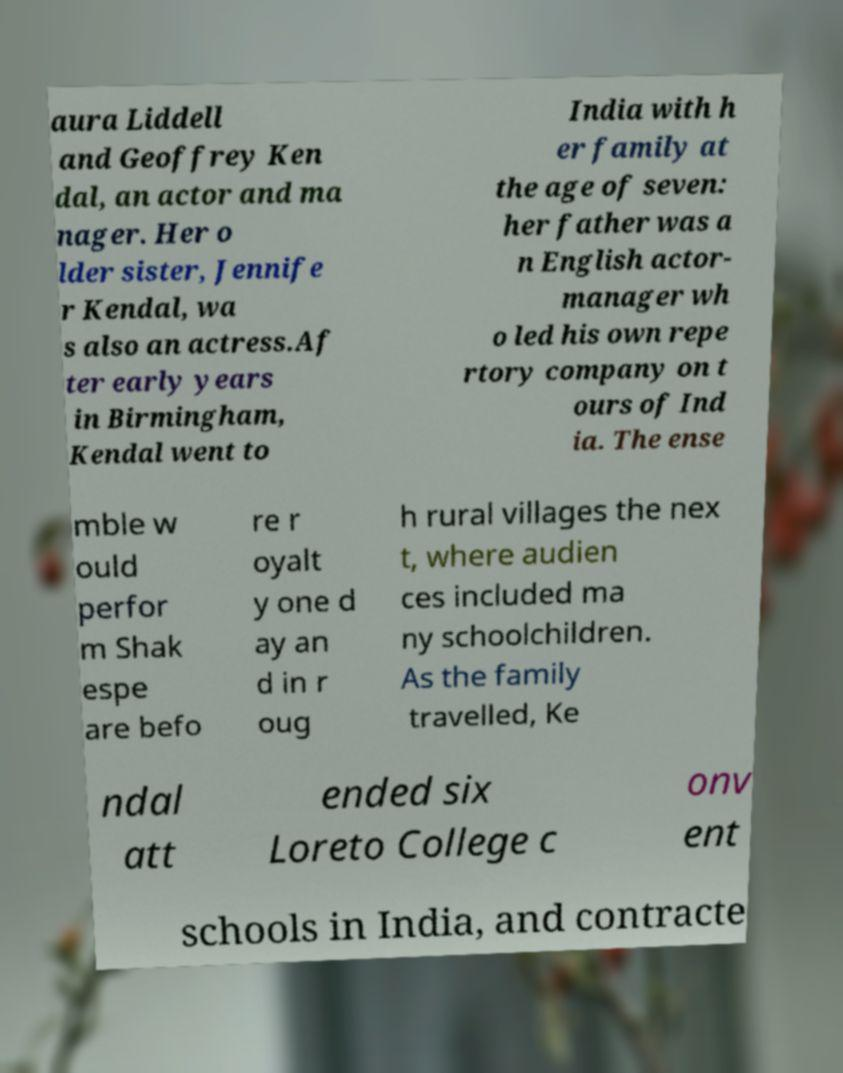Could you assist in decoding the text presented in this image and type it out clearly? aura Liddell and Geoffrey Ken dal, an actor and ma nager. Her o lder sister, Jennife r Kendal, wa s also an actress.Af ter early years in Birmingham, Kendal went to India with h er family at the age of seven: her father was a n English actor- manager wh o led his own repe rtory company on t ours of Ind ia. The ense mble w ould perfor m Shak espe are befo re r oyalt y one d ay an d in r oug h rural villages the nex t, where audien ces included ma ny schoolchildren. As the family travelled, Ke ndal att ended six Loreto College c onv ent schools in India, and contracte 